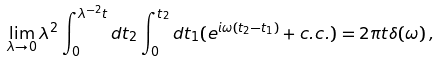Convert formula to latex. <formula><loc_0><loc_0><loc_500><loc_500>\lim _ { \lambda \to 0 } \lambda ^ { 2 } \int ^ { \lambda ^ { - 2 } t } _ { 0 } d t _ { 2 } \int ^ { t _ { 2 } } _ { 0 } d t _ { 1 } ( e ^ { i \omega ( t _ { 2 } - t _ { 1 } ) } + c . c . ) = 2 \pi t \delta ( \omega ) \, ,</formula> 